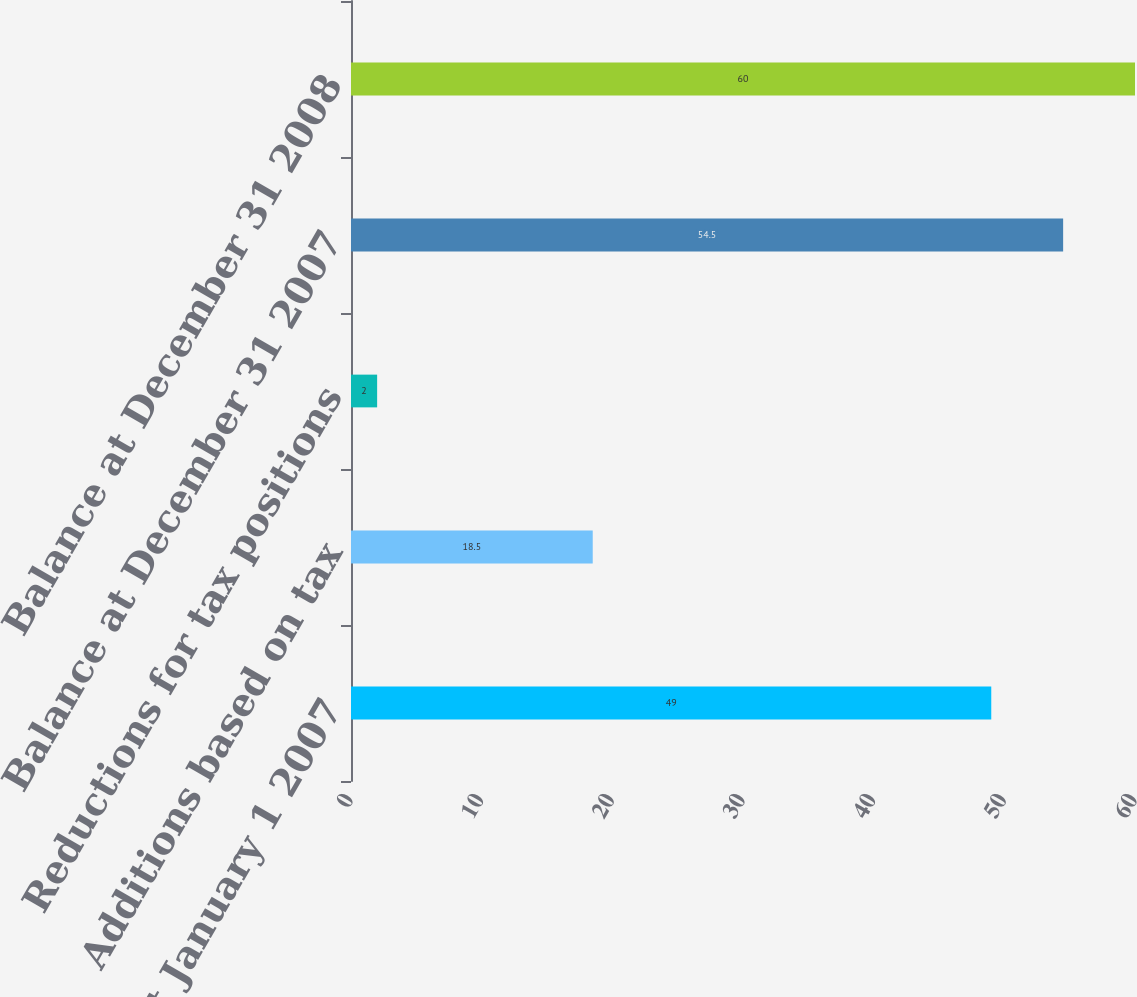<chart> <loc_0><loc_0><loc_500><loc_500><bar_chart><fcel>Balance at January 1 2007<fcel>Additions based on tax<fcel>Reductions for tax positions<fcel>Balance at December 31 2007<fcel>Balance at December 31 2008<nl><fcel>49<fcel>18.5<fcel>2<fcel>54.5<fcel>60<nl></chart> 